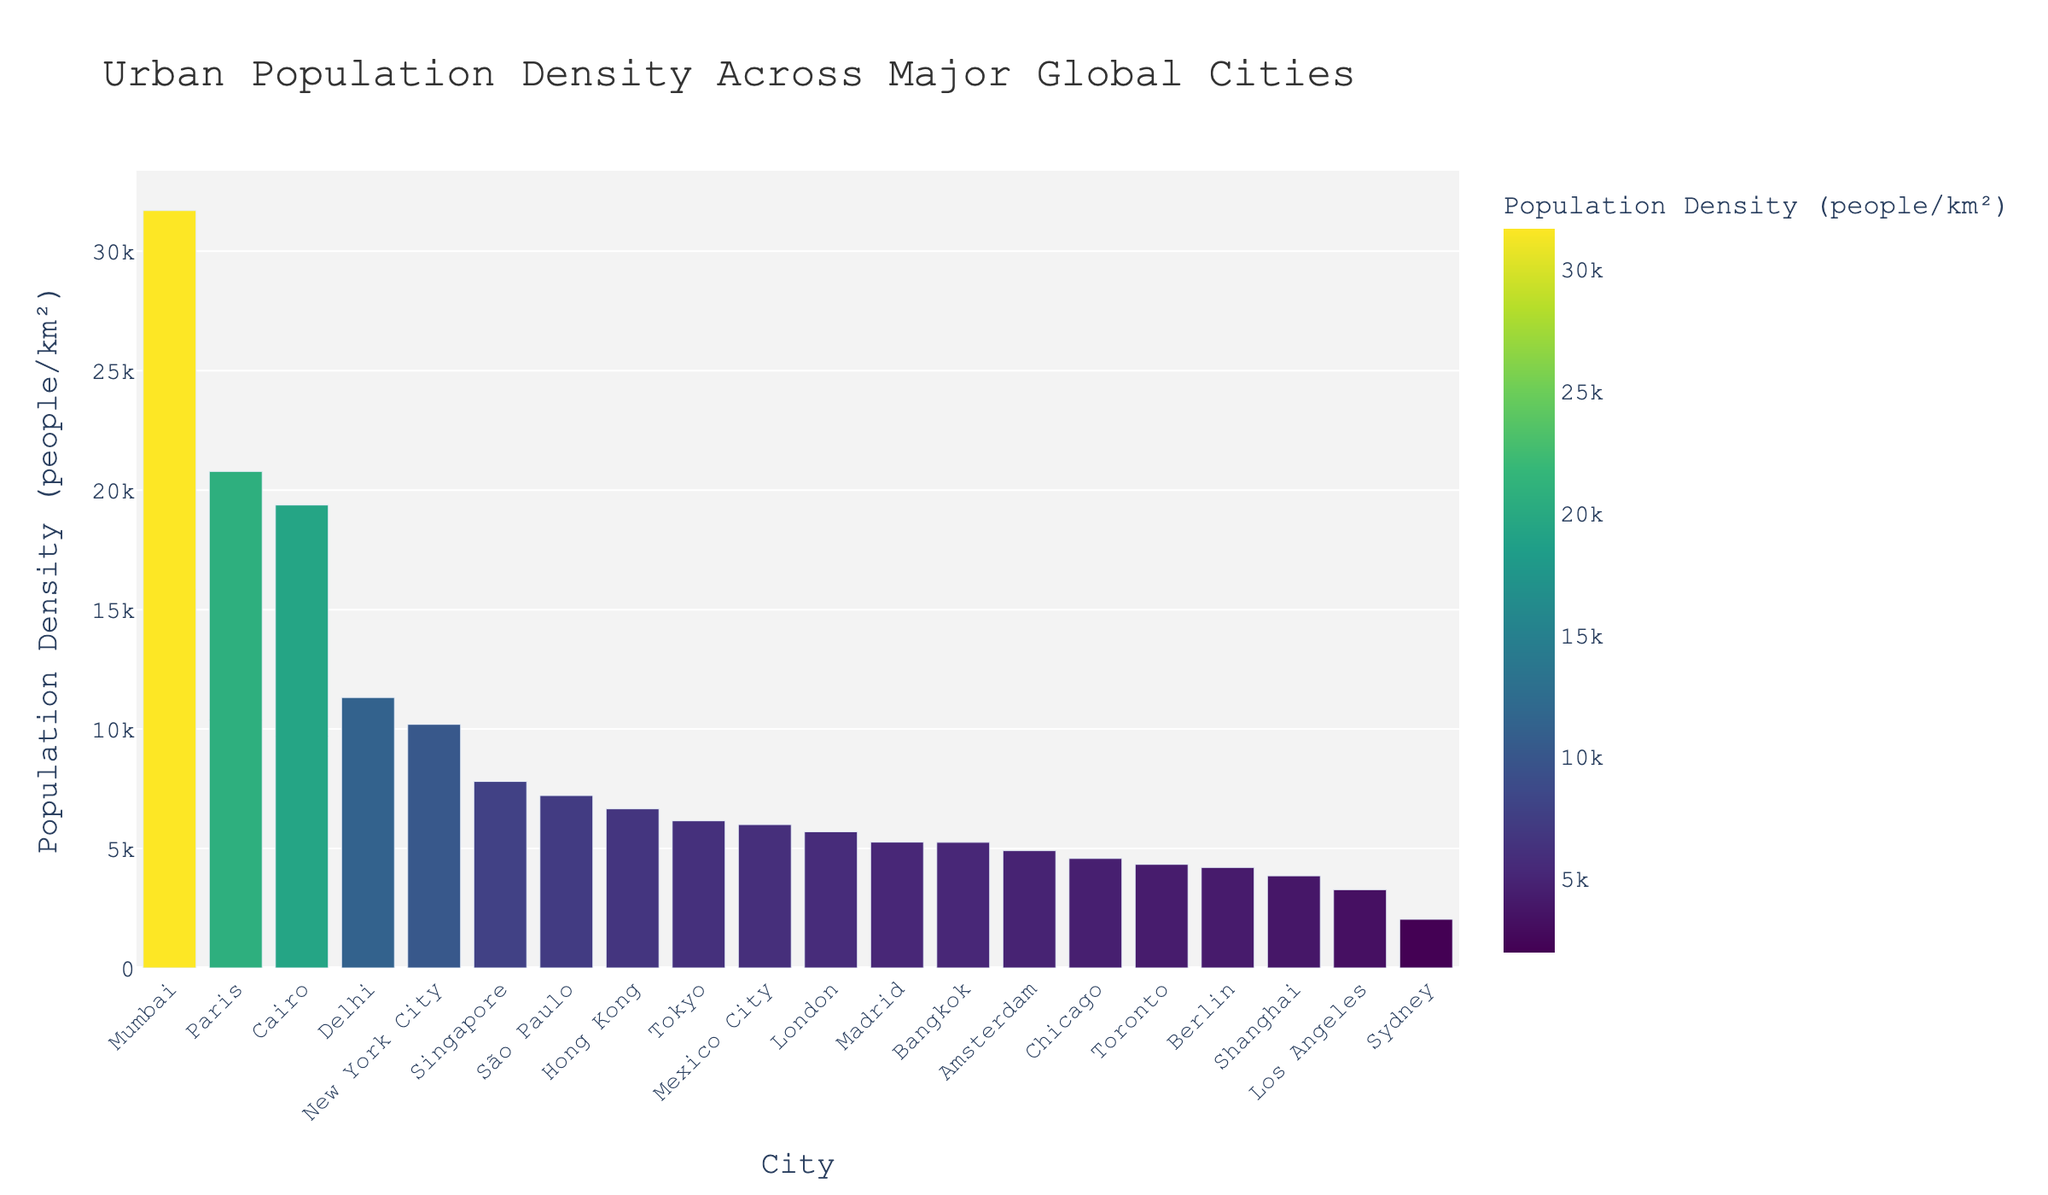Which city has the highest population density? The bar chart shows the population density of various cities. The tallest bar represents Mumbai.
Answer: Mumbai Which city has the lowest population density? The shortest bar represents the city with the lowest population density. The bar for Sydney is the shortest.
Answer: Sydney Is the population density of New York City higher or lower than that of London? Comparing the heights of the two bars, the bar for New York City is taller than the bar for London.
Answer: Higher What is the population density difference between Paris and Tokyo? Paris has a density of 20781 people/km², while Tokyo has 6158 people/km². The difference is 20781 - 6158.
Answer: 14623 What is the average population density of the cities with densities above 10,000 people/km²? Cities above 10,000 people/km² are Mumbai (31700), New York City (10194), Paris (20781), Cairo (19376), and Delhi (11320). The average is (31700 + 10194 + 20781 + 19376 + 11320) / 5.
Answer: 18674.2 Which three cities have the most similar population densities? Observing the height of the bars, Bangkok (5258), Madrid (5265), and London (5701) have bars of similar height.
Answer: Bangkok, Madrid, and London How many cities have population densities greater than 15,000 people/km²? The cities are Mumbai, Paris, Cairo. Counting these gives the total number.
Answer: 3 Which city has a population density closest to the median population density of all the cities? To find the median, list all densities in order and find the middle value. The median is between the 10th and 11th values, which are 6000 and 6158. The city closest to this is Tokyo (6158).
Answer: Tokyo 